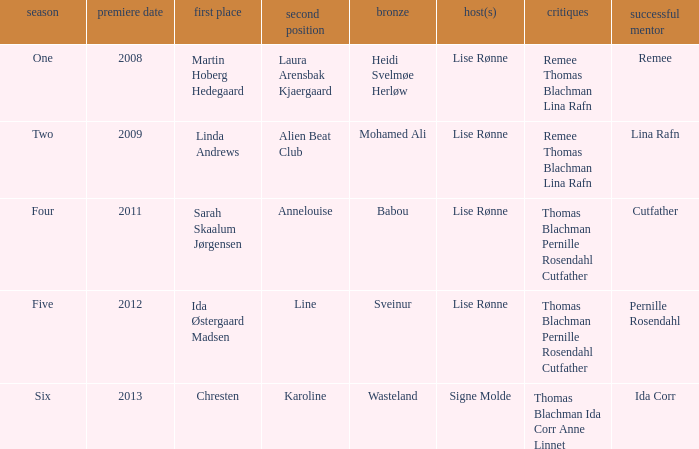Which season did Ida Corr win? Six. Could you parse the entire table? {'header': ['season', 'premiere date', 'first place', 'second position', 'bronze', 'host(s)', 'critiques', 'successful mentor'], 'rows': [['One', '2008', 'Martin Hoberg Hedegaard', 'Laura Arensbak Kjaergaard', 'Heidi Svelmøe Herløw', 'Lise Rønne', 'Remee Thomas Blachman Lina Rafn', 'Remee'], ['Two', '2009', 'Linda Andrews', 'Alien Beat Club', 'Mohamed Ali', 'Lise Rønne', 'Remee Thomas Blachman Lina Rafn', 'Lina Rafn'], ['Four', '2011', 'Sarah Skaalum Jørgensen', 'Annelouise', 'Babou', 'Lise Rønne', 'Thomas Blachman Pernille Rosendahl Cutfather', 'Cutfather'], ['Five', '2012', 'Ida Østergaard Madsen', 'Line', 'Sveinur', 'Lise Rønne', 'Thomas Blachman Pernille Rosendahl Cutfather', 'Pernille Rosendahl'], ['Six', '2013', 'Chresten', 'Karoline', 'Wasteland', 'Signe Molde', 'Thomas Blachman Ida Corr Anne Linnet', 'Ida Corr']]} 